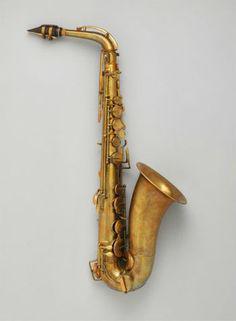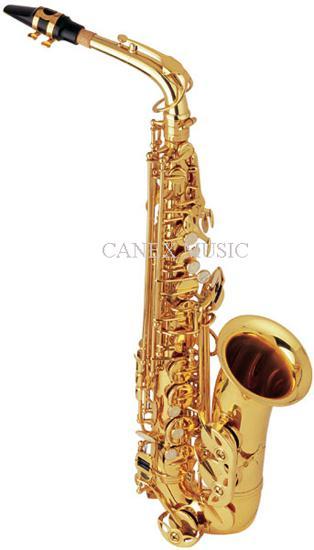The first image is the image on the left, the second image is the image on the right. Considering the images on both sides, is "The entire length of one saxophone is shown in each image." valid? Answer yes or no. Yes. The first image is the image on the left, the second image is the image on the right. Examine the images to the left and right. Is the description "Each image shows a single upright instrument on a plain background." accurate? Answer yes or no. Yes. 